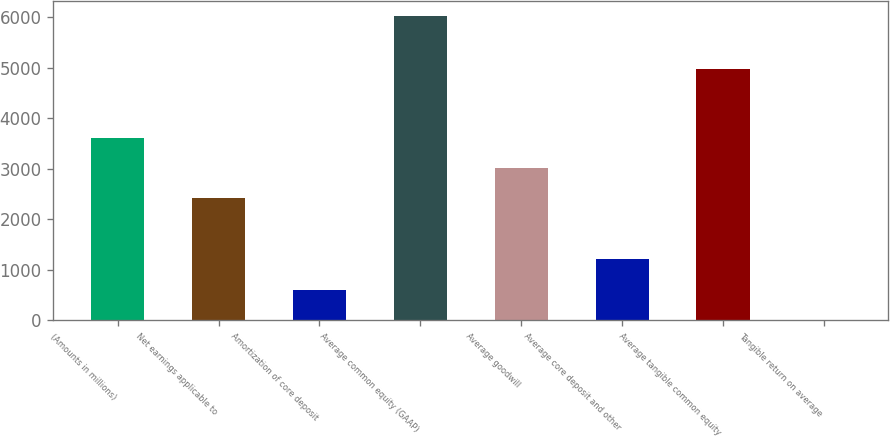<chart> <loc_0><loc_0><loc_500><loc_500><bar_chart><fcel>(Amounts in millions)<fcel>Net earnings applicable to<fcel>Amortization of core deposit<fcel>Average common equity (GAAP)<fcel>Average goodwill<fcel>Average core deposit and other<fcel>Average tangible common equity<fcel>Tangible return on average<nl><fcel>3617.08<fcel>2413.62<fcel>608.43<fcel>6024<fcel>3015.35<fcel>1210.16<fcel>4979<fcel>6.7<nl></chart> 